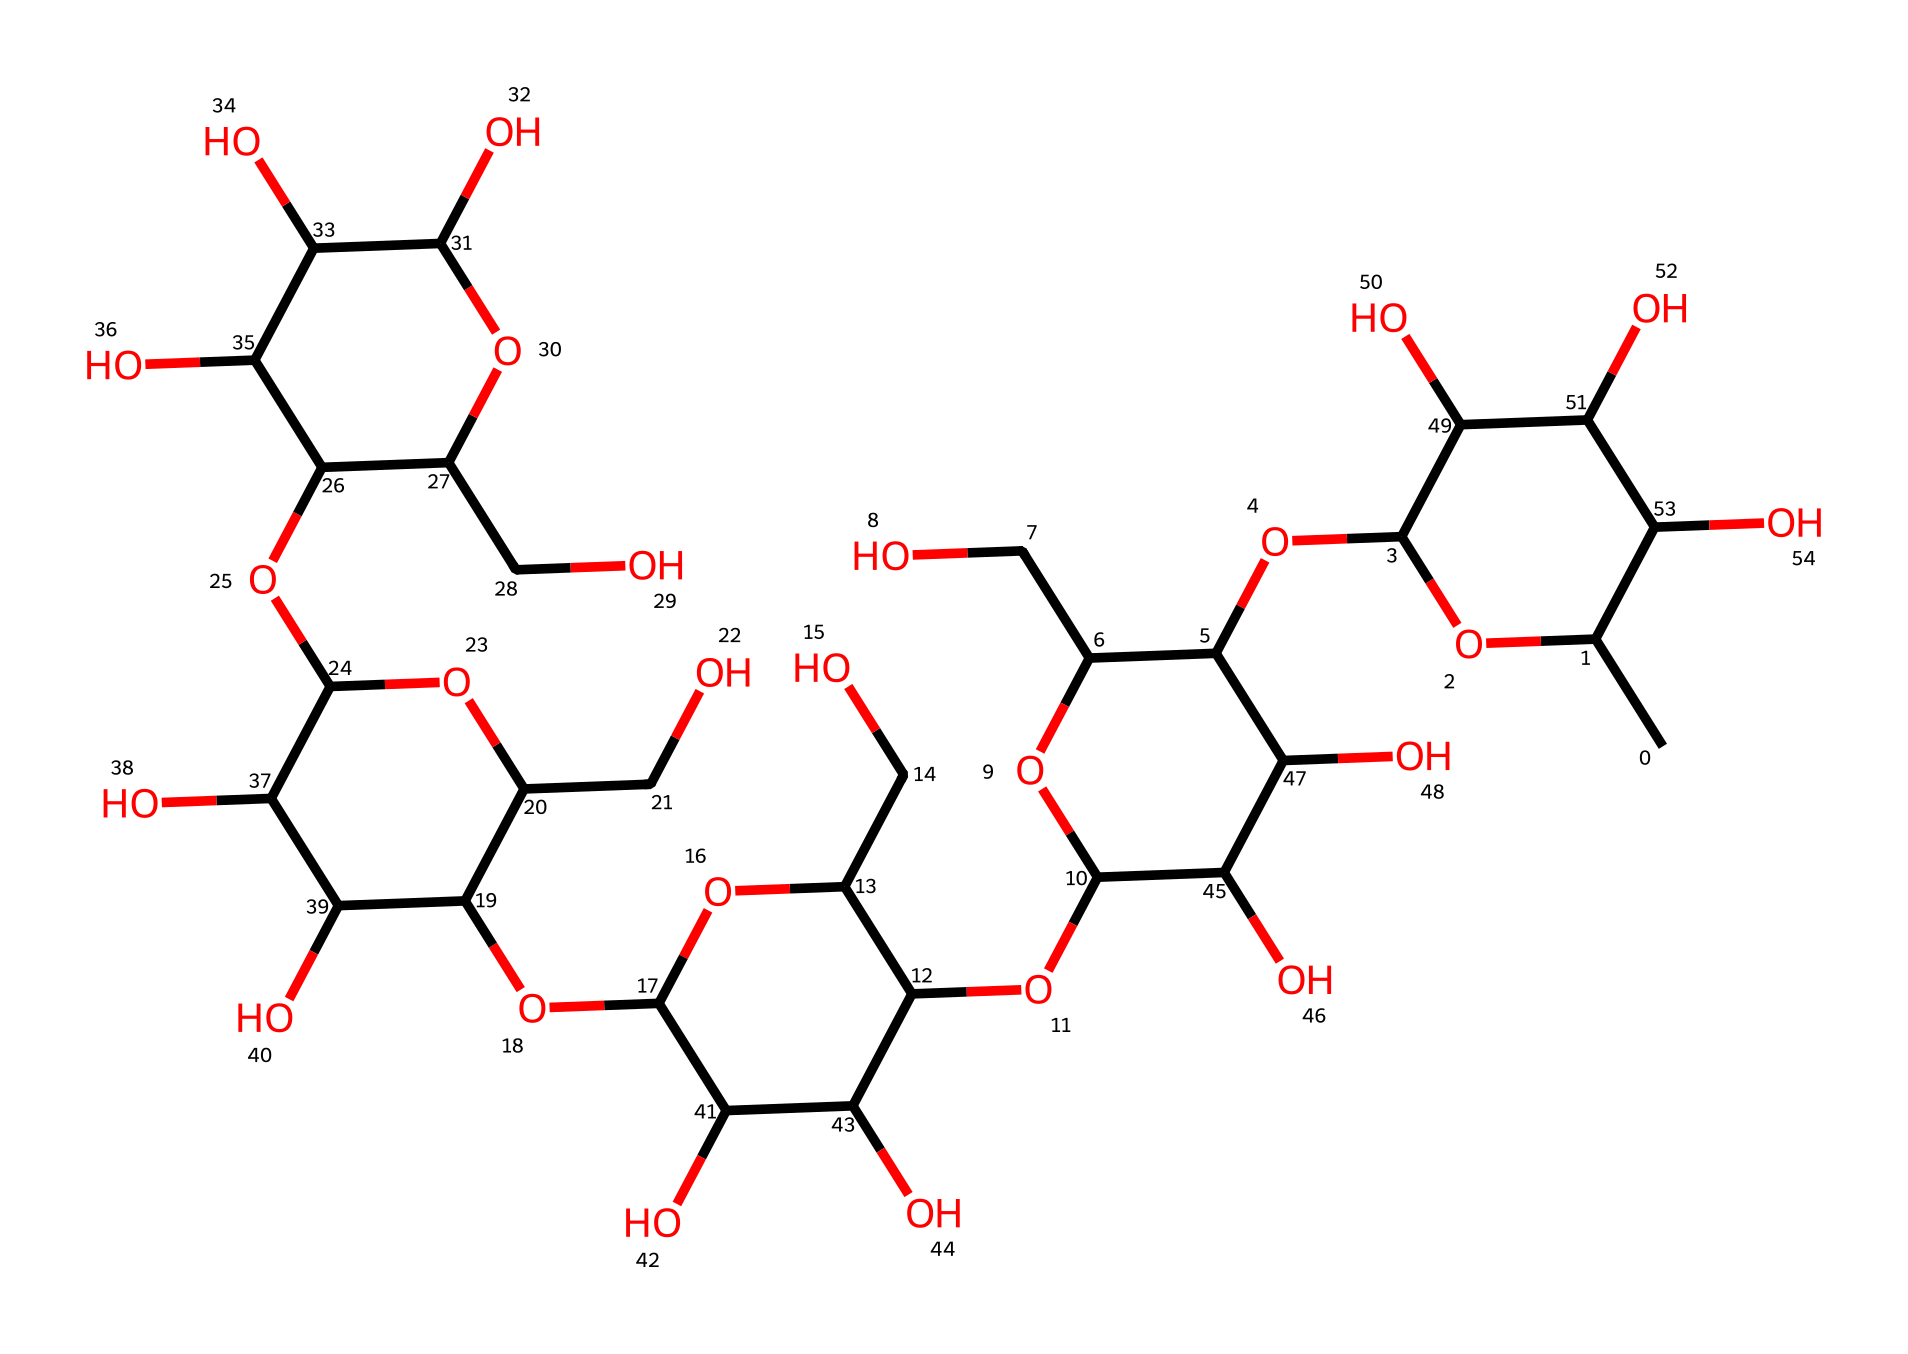What is the primary functional group present in xanthan gum? The primary functional group present in xanthan gum is the hydroxyl (-OH) group, as evidenced by the numerous -OH groups throughout the chemical structure.
Answer: hydroxyl How many ring structures are evident in the SMILES representation of xanthan gum? The SMILES representation shows several cyclic structures in the formula, indicating that it contains multiple ring structures within its overall chemical layout.
Answer: multiple What type of viscosity behavior does xanthan gum demonstrate under stress? Xanthan gum exhibits shear-thinning behavior, a characteristic of Non-Newtonian fluids, meaning its viscosity decreases under applied stress or shear force.
Answer: shear-thinning How many carbon atoms are there in the structure of xanthan gum? By analyzing the structure represented in the SMILES notation, one can count a total of 25 carbon atoms present in the molecular formula.
Answer: 25 Why is xanthan gum considered a good dental impression material? Xanthan gum's non-Newtonian properties, such as its ability to maintain shape under compression while flowing under stress, make it ideal for creating accurate dental impressions.
Answer: non-Newtonian properties What property allows xanthan gum to form a gel-like consistency when hydrated? The ability to form hydrogen bonds among the numerous hydroxyl groups allows xanthan gum to swell and create a gel-like consistency when mixed with water.
Answer: hydrogen bonding 